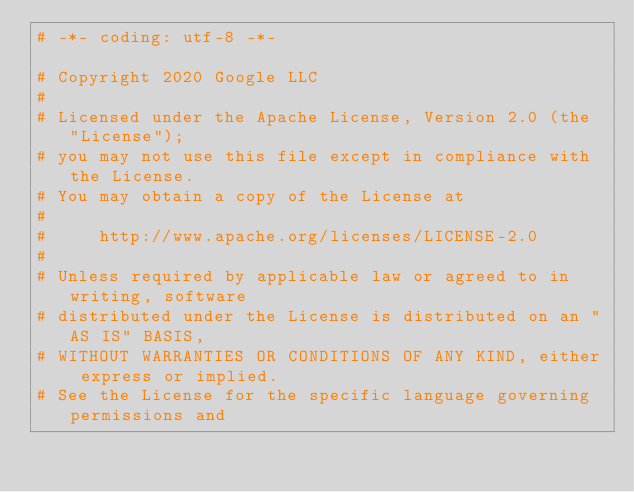Convert code to text. <code><loc_0><loc_0><loc_500><loc_500><_Python_># -*- coding: utf-8 -*-

# Copyright 2020 Google LLC
#
# Licensed under the Apache License, Version 2.0 (the "License");
# you may not use this file except in compliance with the License.
# You may obtain a copy of the License at
#
#     http://www.apache.org/licenses/LICENSE-2.0
#
# Unless required by applicable law or agreed to in writing, software
# distributed under the License is distributed on an "AS IS" BASIS,
# WITHOUT WARRANTIES OR CONDITIONS OF ANY KIND, either express or implied.
# See the License for the specific language governing permissions and</code> 